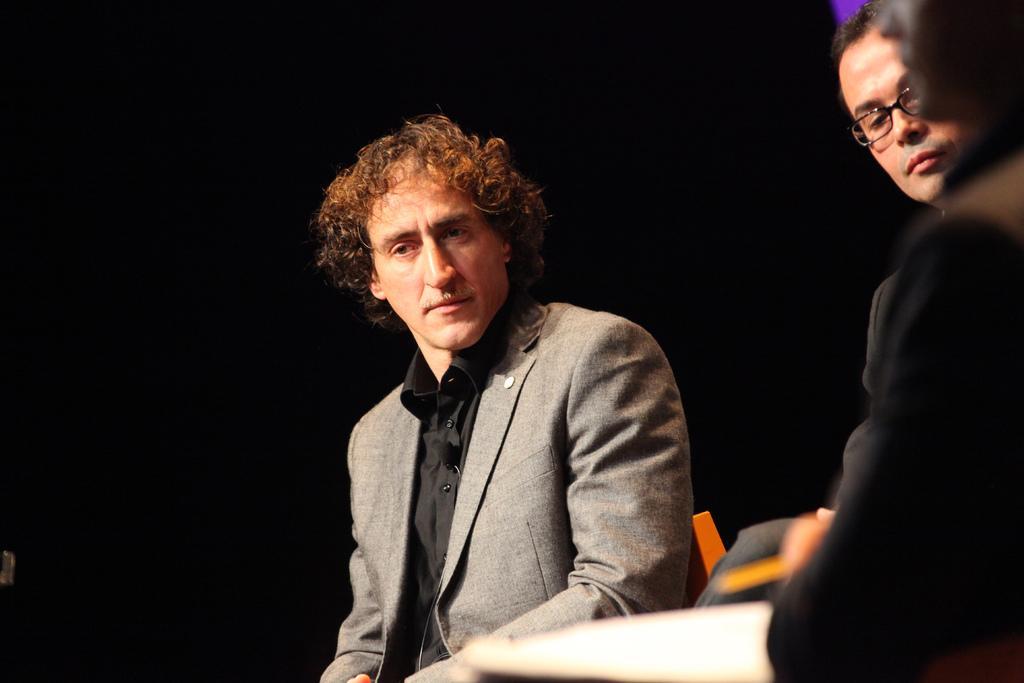How would you summarize this image in a sentence or two? In this image, on the right side, we can see two persons. In the middle of the image, we can see a man sitting on the chair. In the background, we can see black color. 